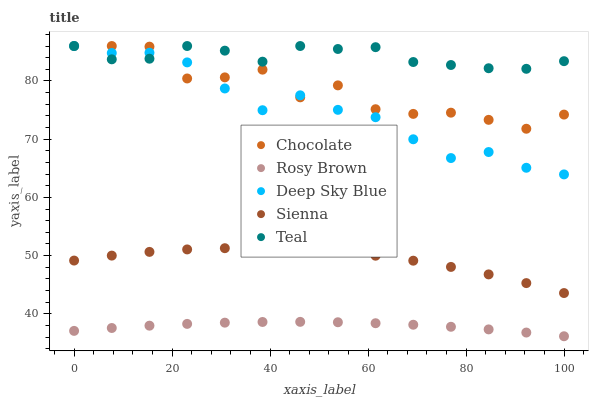Does Rosy Brown have the minimum area under the curve?
Answer yes or no. Yes. Does Teal have the maximum area under the curve?
Answer yes or no. Yes. Does Teal have the minimum area under the curve?
Answer yes or no. No. Does Rosy Brown have the maximum area under the curve?
Answer yes or no. No. Is Rosy Brown the smoothest?
Answer yes or no. Yes. Is Chocolate the roughest?
Answer yes or no. Yes. Is Teal the smoothest?
Answer yes or no. No. Is Teal the roughest?
Answer yes or no. No. Does Rosy Brown have the lowest value?
Answer yes or no. Yes. Does Teal have the lowest value?
Answer yes or no. No. Does Chocolate have the highest value?
Answer yes or no. Yes. Does Rosy Brown have the highest value?
Answer yes or no. No. Is Sienna less than Teal?
Answer yes or no. Yes. Is Chocolate greater than Sienna?
Answer yes or no. Yes. Does Deep Sky Blue intersect Chocolate?
Answer yes or no. Yes. Is Deep Sky Blue less than Chocolate?
Answer yes or no. No. Is Deep Sky Blue greater than Chocolate?
Answer yes or no. No. Does Sienna intersect Teal?
Answer yes or no. No. 